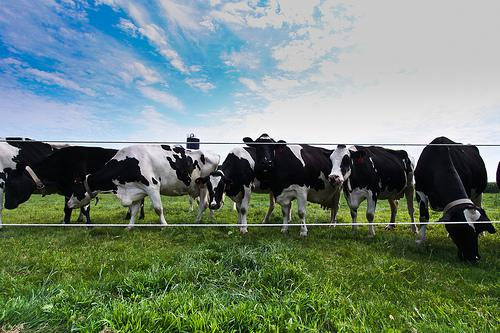Question: why is there a fence?
Choices:
A. To keep the cows in.
B. To stop the horses form escaping.
C. To keep the dog in.
D. To keep the deer out.
Answer with the letter. Answer: A Question: how many cows?
Choices:
A. Eight.
B. Seven.
C. Nine.
D. Ten.
Answer with the letter. Answer: B Question: who would care for these animals?
Choices:
A. A pilot.
B. A plumber.
C. A farmer.
D. A mechanic.
Answer with the letter. Answer: C Question: what color are the clouds?
Choices:
A. White.
B. Gray.
C. Gray and white.
D. Black.
Answer with the letter. Answer: A Question: where are the cows?
Choices:
A. In a field.
B. In the house.
C. In the river.
D. On the hill.
Answer with the letter. Answer: A 